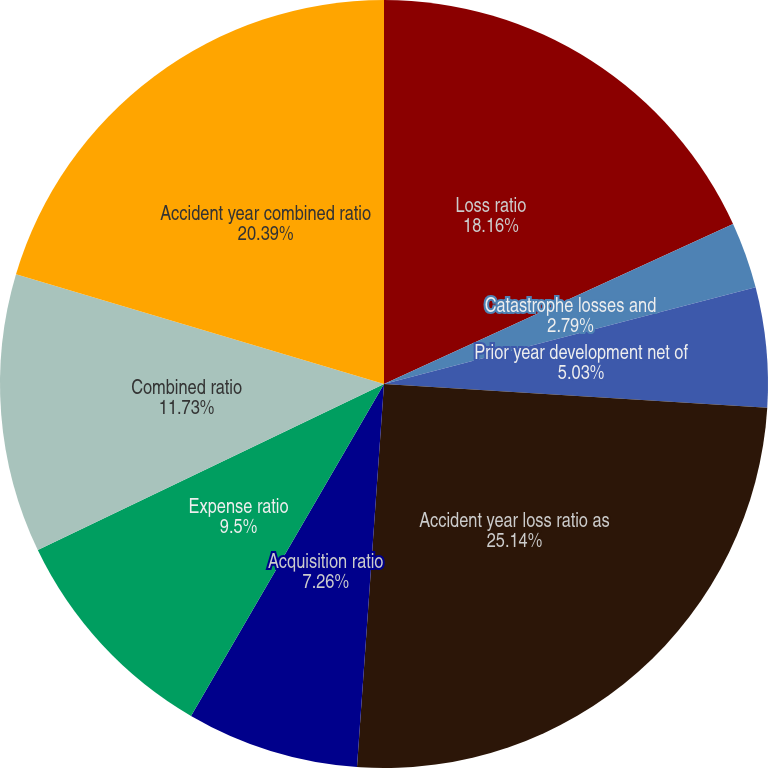Convert chart. <chart><loc_0><loc_0><loc_500><loc_500><pie_chart><fcel>Loss ratio<fcel>Catastrophe losses and<fcel>Prior year development net of<fcel>Accident year loss ratio as<fcel>Acquisition ratio<fcel>Expense ratio<fcel>Combined ratio<fcel>Accident year combined ratio<nl><fcel>18.16%<fcel>2.79%<fcel>5.03%<fcel>25.14%<fcel>7.26%<fcel>9.5%<fcel>11.73%<fcel>20.39%<nl></chart> 